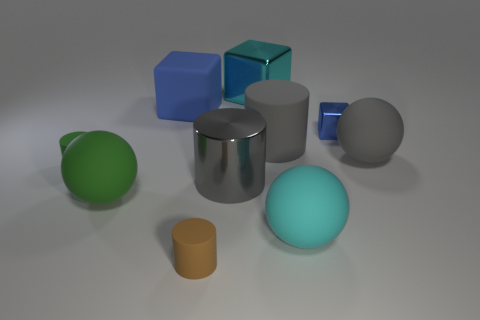Are there any tiny metal objects?
Offer a very short reply. Yes. What is the color of the thing that is both on the left side of the matte block and to the right of the small green cylinder?
Keep it short and to the point. Green. Do the blue block behind the small blue object and the gray metal thing that is behind the cyan matte sphere have the same size?
Offer a very short reply. Yes. How many other things are there of the same size as the brown thing?
Your answer should be compact. 2. What number of small green cylinders are behind the object right of the blue metal cube?
Offer a very short reply. 0. Is the number of big cyan spheres that are behind the tiny green rubber cylinder less than the number of rubber objects?
Make the answer very short. Yes. There is a large gray object in front of the cylinder that is to the left of the cube that is on the left side of the cyan metal block; what shape is it?
Provide a succinct answer. Cylinder. Do the big green object and the blue shiny object have the same shape?
Provide a succinct answer. No. How many other things are there of the same shape as the gray shiny object?
Provide a succinct answer. 3. The shiny thing that is the same size as the cyan cube is what color?
Your answer should be compact. Gray. 